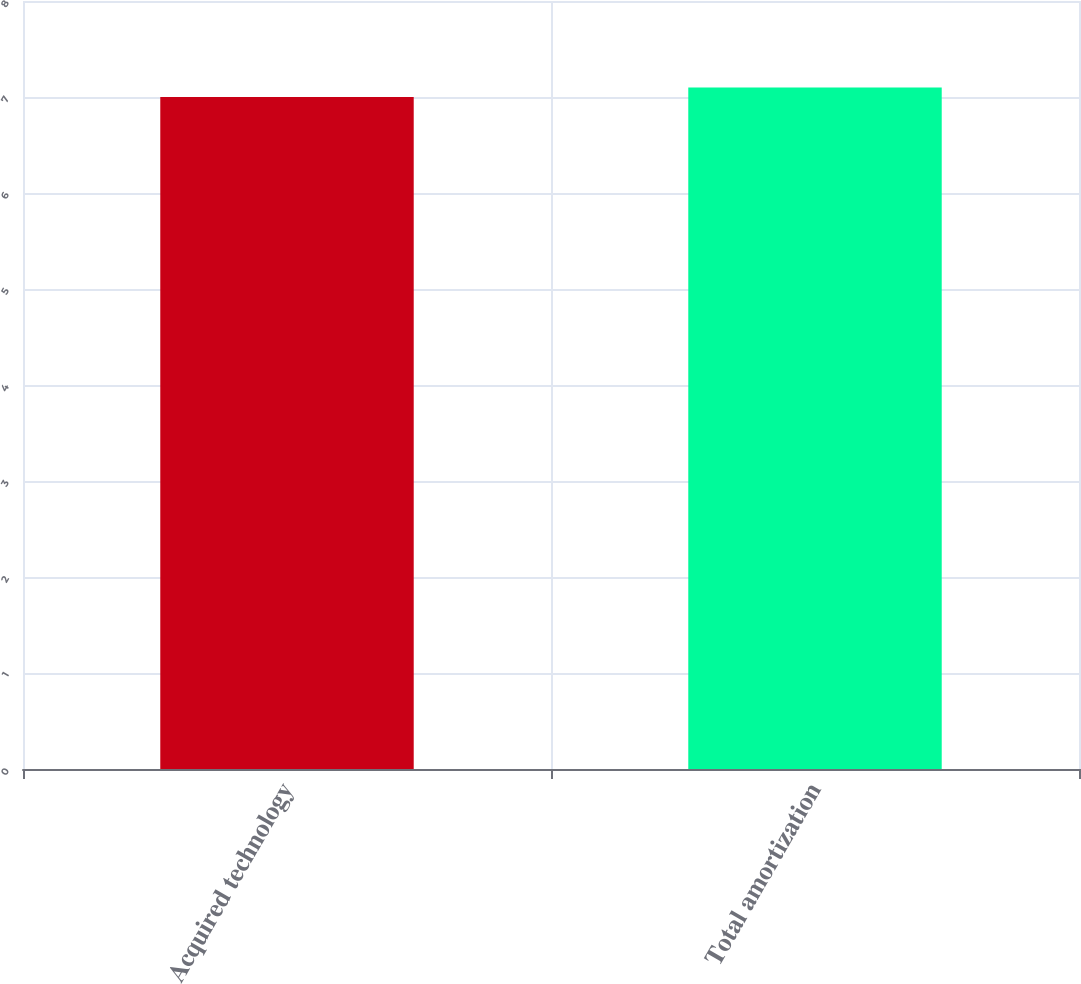Convert chart to OTSL. <chart><loc_0><loc_0><loc_500><loc_500><bar_chart><fcel>Acquired technology<fcel>Total amortization<nl><fcel>7<fcel>7.1<nl></chart> 